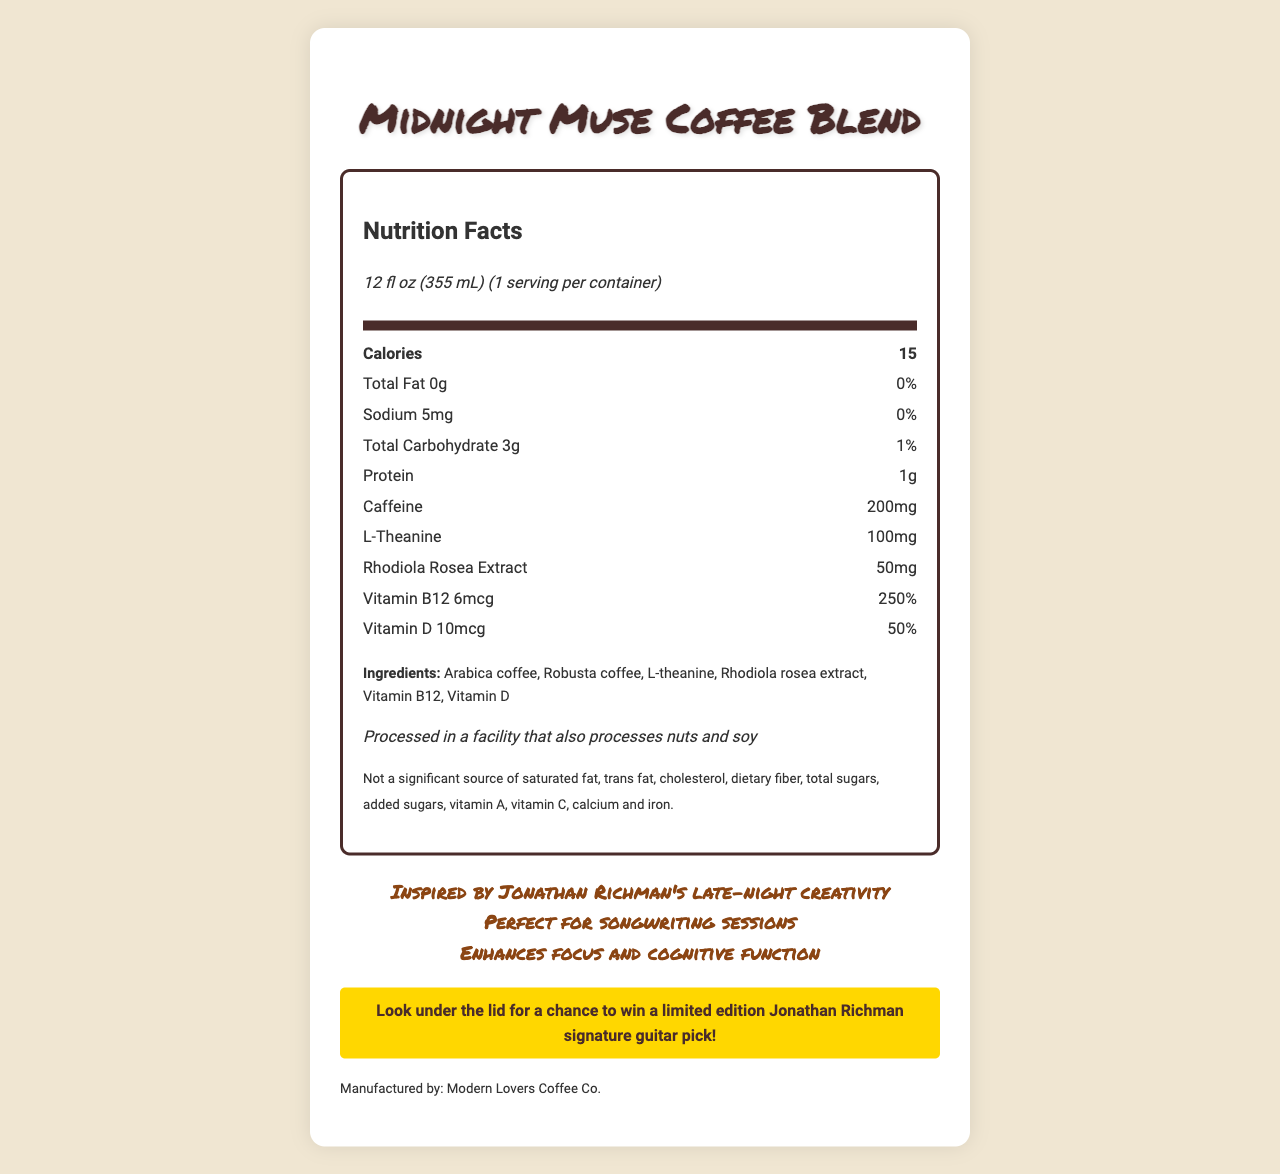where is the Midnight Muse Coffee Blend manufactured? The document states, "Manufactured by: Modern Lovers Coffee Co."
Answer: Modern Lovers Coffee Co. what is the serving size of Midnight Muse Coffee Blend? The document specifically mentions, "serving size: 12 fl oz (355 mL)."
Answer: 12 fl oz (355 mL) how much caffeine is included in one serving of this coffee blend? The nutrient row for caffeine lists 200mg.
Answer: 200mg what ingredients are used in the Midnight Muse Coffee Blend? The ingredients section lists all these items.
Answer: Arabica coffee, Robusta coffee, L-theanine, Rhodiola rosea extract, Vitamin B12, Vitamin D how many calories are in one serving? The document includes a nutrient row for calories which lists 15.
Answer: 15 what is the percentage of daily Vitamin B12 provided? A. 100% B. 150% C. 200% D. 250% The document states, "Vitamin B12 250%."
Answer: D which cognitive enhancer is included in the coffee blend? A. Ginseng B. Rhodiola rosea extract C. Ashwagandha D. L-arginine Rhodiola rosea extract is listed as an ingredient.
Answer: B is this coffee blend a source of dietary fiber? The disclaimer mentions, "Not a significant source of dietary fiber."
Answer: No are there any allergen concerns one should be aware of? The allergen information states, "Processed in a facility that also processes nuts and soy."
Answer: Yes why might this coffee blend be particularly suitable for late-night songwriting sessions? The custom text mentions it is inspired by Jonathan Richman’s creativity and is perfect for songwriting sessions, and it lists ingredients known for cognitive enhancement.
Answer: Because it enhances focus and cognitive function due to its ingredients such as L-theanine and Rhodiola rosea extract and was inspired by Jonathan Richman's late-night creativity. what is promoted under the lid of the container? The promo section states, "Look under the lid for a chance to win a limited edition Jonathan Richman signature guitar pick!"
Answer: A chance to win a limited edition Jonathan Richman signature guitar pick is vitamin C included in the Midnight Muse Coffee Blend? The disclaimer section mentions it's not a significant source of Vitamin C.
Answer: No what is the product name mentioned on the nutrition label? The title and header of the document clearly state the product name as "Midnight Muse Coffee Blend".
Answer: Midnight Muse Coffee Blend how much protein does the Midnight Muse Coffee Blend provide per serving? The nutrient row for protein lists 1g.
Answer: 1g Summarize the main idea of the document. The document provides detailed nutritional information and promotional context about the Midnight Muse Coffee Blend, emphasizing its suitability for late-night creativity and focus.
Answer: The Midnight Muse Coffee Blend is a specialty coffee designed for enhancing creativity and focus during late-night songwriting sessions. It contains cognitive enhancers, such as L-theanine and Rhodiola rosea extract, and is produced by Modern Lovers Coffee Co. It provides minimal calories, fat, and sodium, but contains significant amounts of caffeine and vitamins B12 and D. The coffee blend is inspired by Jonathan Richman and also includes a promotional offer to win a guitar pick. who created the promotional guitar picks? The document mentions that there's a chance to win a limited edition Jonathan Richman signature guitar pick, but it does not state who created or manufactured them.
Answer: Not enough information 